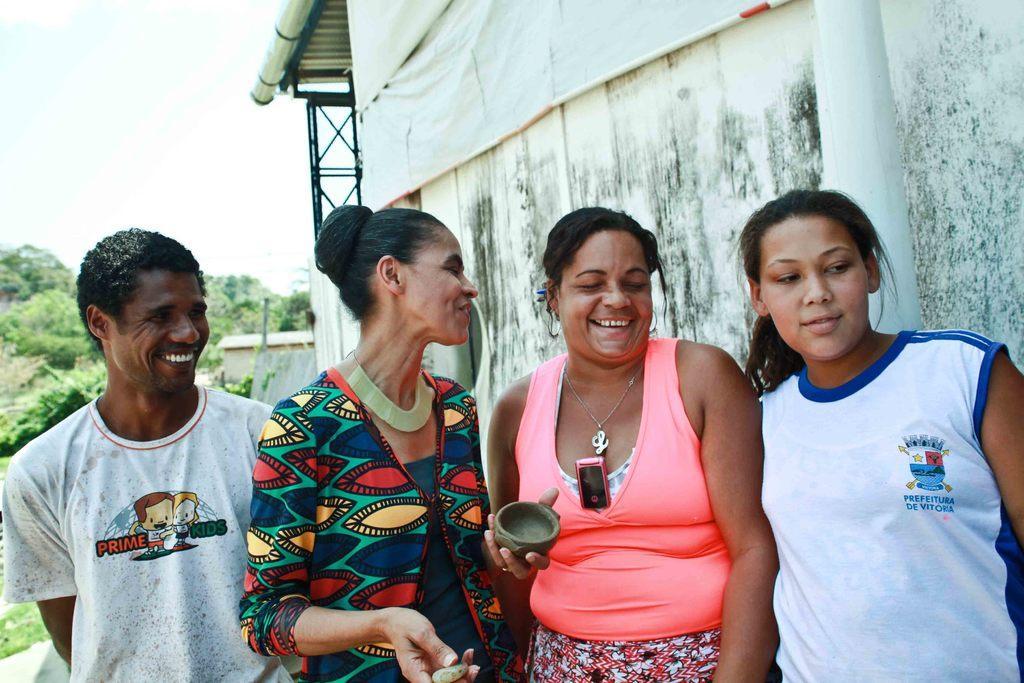Could you give a brief overview of what you see in this image? In this image I can see three women and a man wearing white colored t shirt are standing. In the background I can see a building, a white colored pole, few trees which are green in color and the sky. 